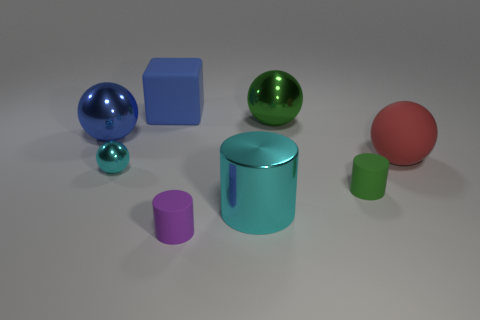What size is the shiny sphere that is right of the blue object that is on the right side of the large blue metal sphere?
Make the answer very short. Large. How many green objects are balls or cubes?
Your answer should be very brief. 1. Is the number of small green cylinders behind the blue rubber thing less than the number of green balls to the left of the green metallic ball?
Your answer should be very brief. No. Is the size of the shiny cylinder the same as the blue object that is on the left side of the cyan shiny sphere?
Make the answer very short. Yes. How many rubber objects have the same size as the green cylinder?
Your answer should be compact. 1. What number of large things are gray things or red matte spheres?
Your answer should be very brief. 1. Is there a cyan shiny sphere?
Make the answer very short. Yes. Are there more red things that are in front of the green sphere than small purple things on the right side of the red object?
Ensure brevity in your answer.  Yes. There is a metallic ball that is in front of the large blue thing that is left of the small cyan sphere; what color is it?
Provide a short and direct response. Cyan. Are there any other big matte blocks that have the same color as the large matte cube?
Your response must be concise. No. 